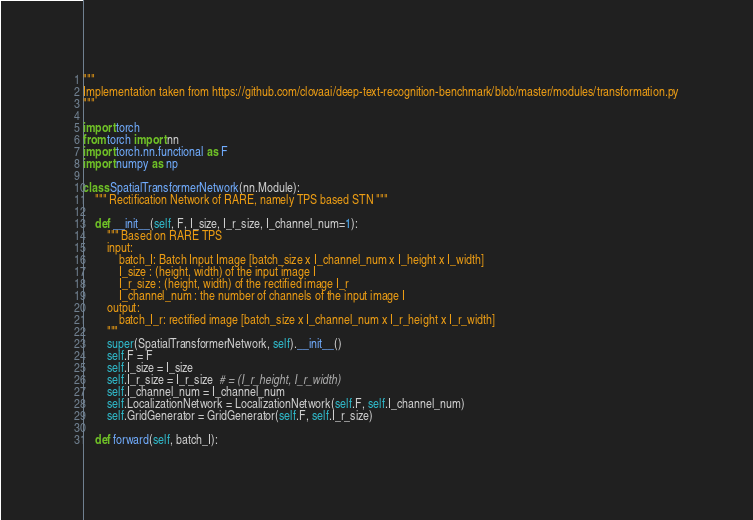Convert code to text. <code><loc_0><loc_0><loc_500><loc_500><_Python_>"""
Implementation taken from https://github.com/clovaai/deep-text-recognition-benchmark/blob/master/modules/transformation.py
"""

import torch
from torch import nn
import torch.nn.functional as F
import numpy as np

class SpatialTransformerNetwork(nn.Module):
    """ Rectification Network of RARE, namely TPS based STN """

    def __init__(self, F, I_size, I_r_size, I_channel_num=1):
        """ Based on RARE TPS
        input:
            batch_I: Batch Input Image [batch_size x I_channel_num x I_height x I_width]
            I_size : (height, width) of the input image I
            I_r_size : (height, width) of the rectified image I_r
            I_channel_num : the number of channels of the input image I
        output:
            batch_I_r: rectified image [batch_size x I_channel_num x I_r_height x I_r_width]
        """
        super(SpatialTransformerNetwork, self).__init__()
        self.F = F
        self.I_size = I_size
        self.I_r_size = I_r_size  # = (I_r_height, I_r_width)
        self.I_channel_num = I_channel_num
        self.LocalizationNetwork = LocalizationNetwork(self.F, self.I_channel_num)
        self.GridGenerator = GridGenerator(self.F, self.I_r_size)

    def forward(self, batch_I):</code> 